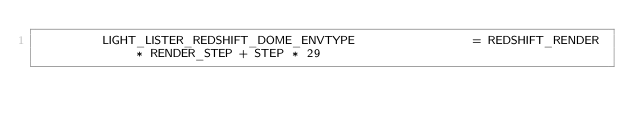Convert code to text. <code><loc_0><loc_0><loc_500><loc_500><_Python_>         LIGHT_LISTER_REDSHIFT_DOME_ENVTYPE                = REDSHIFT_RENDER * RENDER_STEP + STEP * 29</code> 